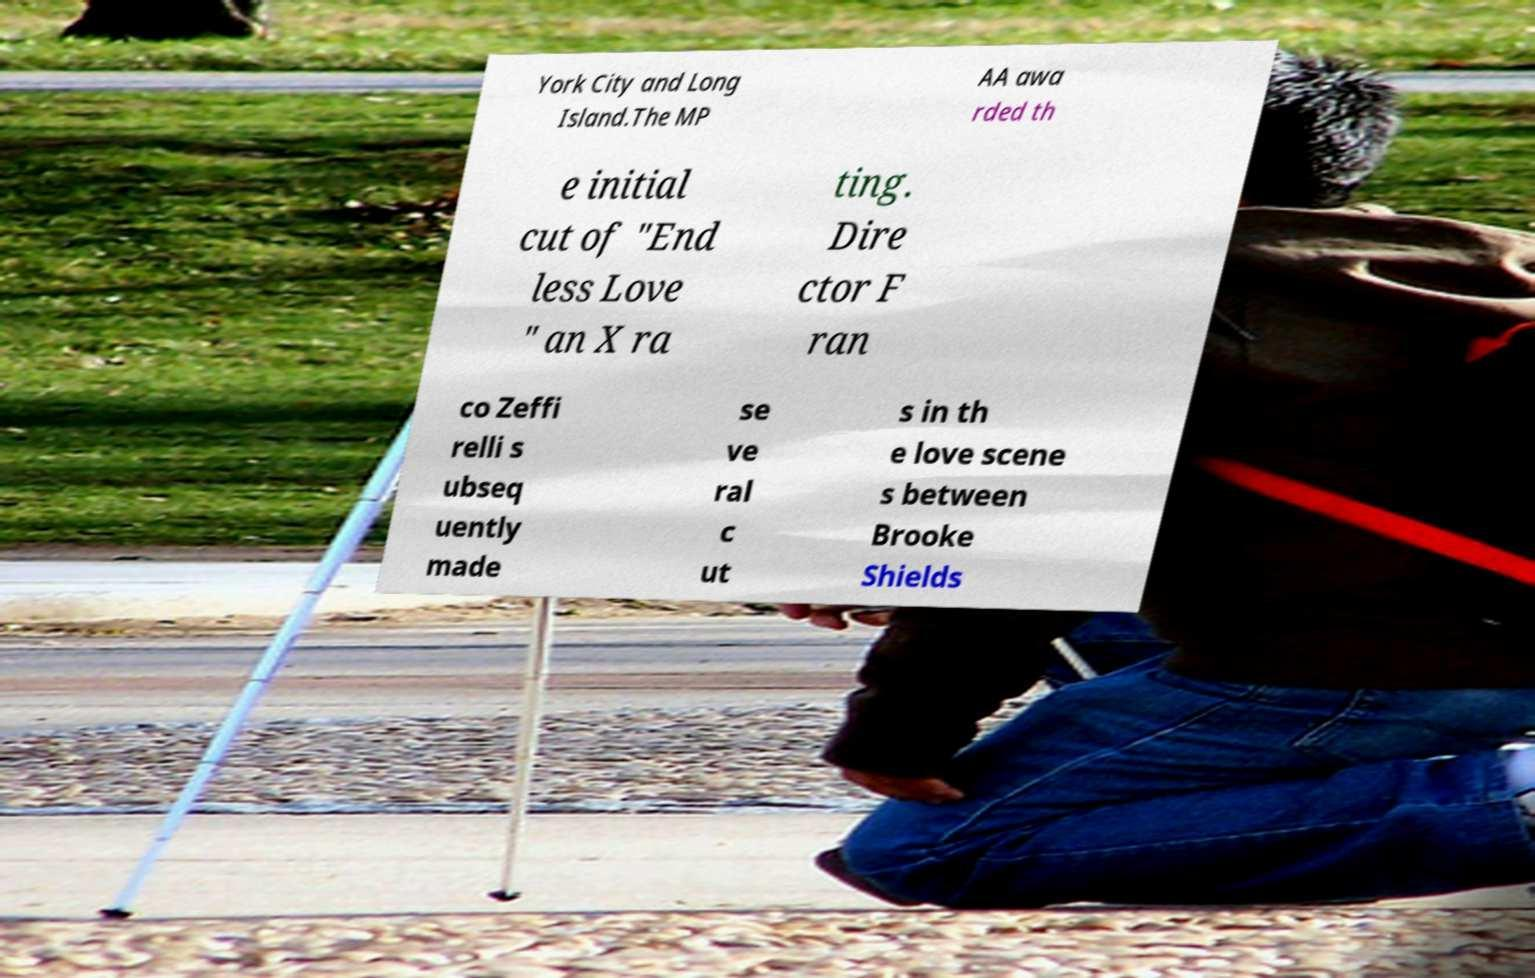Please read and relay the text visible in this image. What does it say? York City and Long Island.The MP AA awa rded th e initial cut of "End less Love " an X ra ting. Dire ctor F ran co Zeffi relli s ubseq uently made se ve ral c ut s in th e love scene s between Brooke Shields 